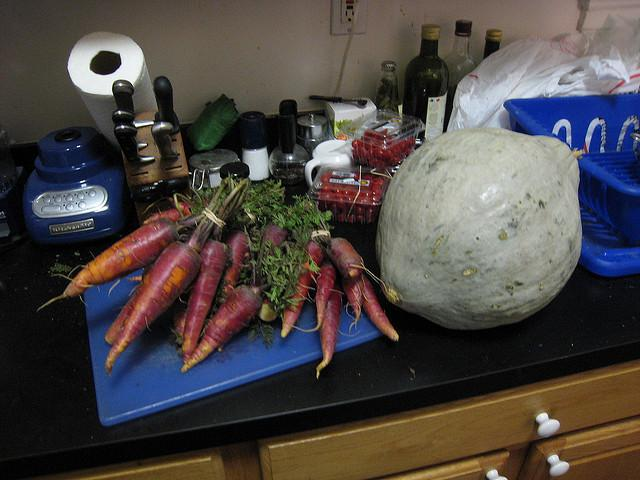Which food is rich in vitamin A? Please explain your reasoning. carrot. Carrots are rich in vitamin a 